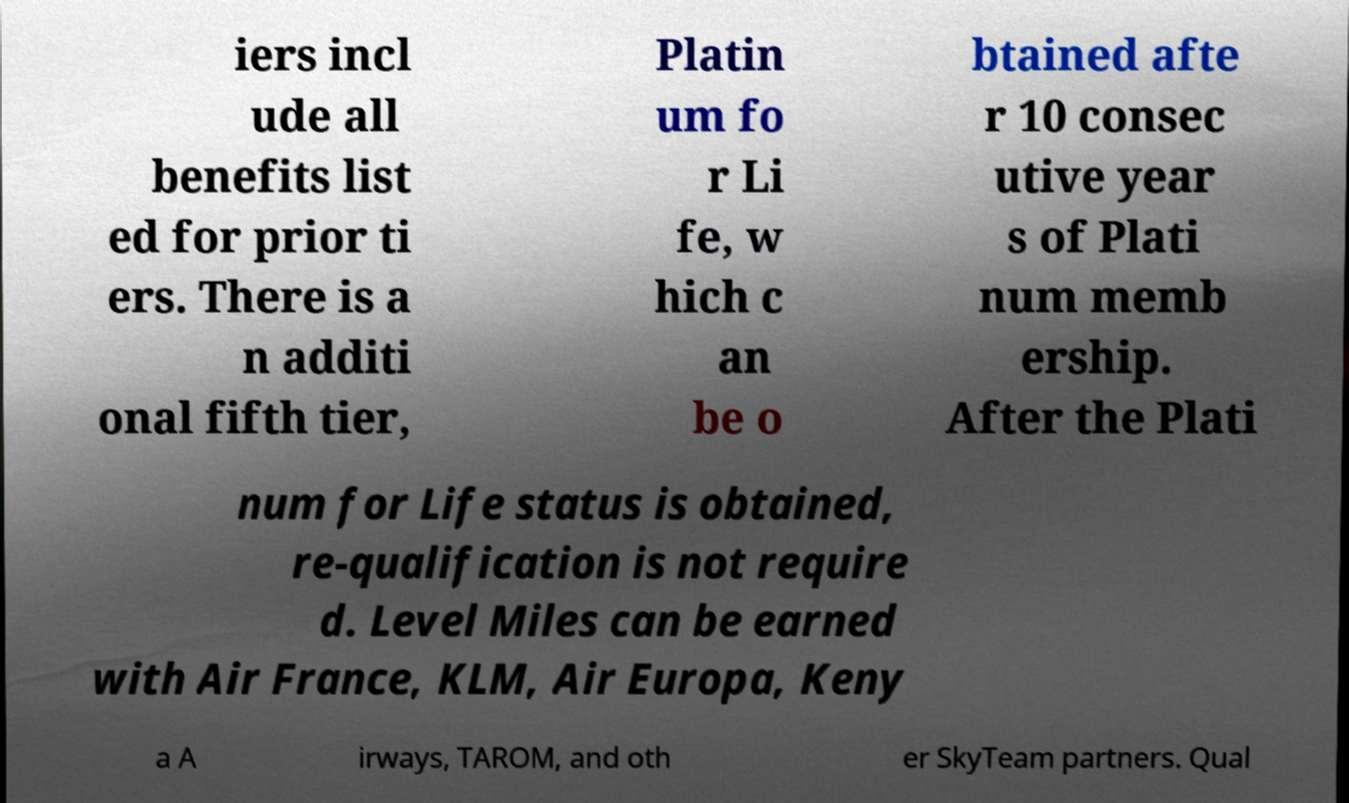For documentation purposes, I need the text within this image transcribed. Could you provide that? iers incl ude all benefits list ed for prior ti ers. There is a n additi onal fifth tier, Platin um fo r Li fe, w hich c an be o btained afte r 10 consec utive year s of Plati num memb ership. After the Plati num for Life status is obtained, re-qualification is not require d. Level Miles can be earned with Air France, KLM, Air Europa, Keny a A irways, TAROM, and oth er SkyTeam partners. Qual 